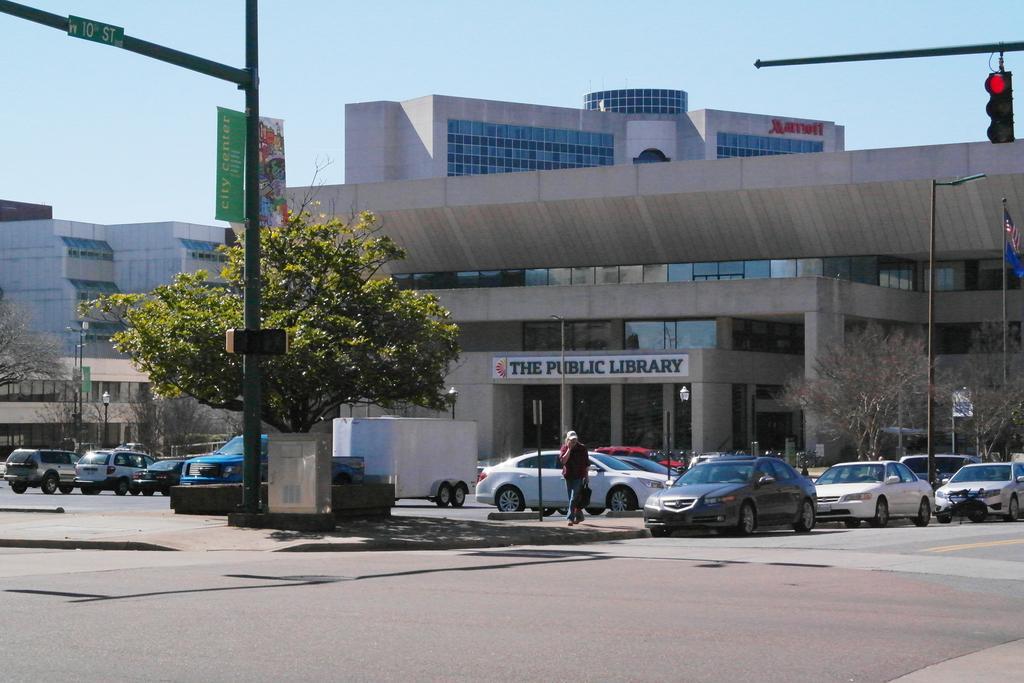Please provide a concise description of this image. In the picture I can see vehicles and people walking on the ground. In the background I can see trees, buildings, pole lights, the sky, traffic lights and some other things. 